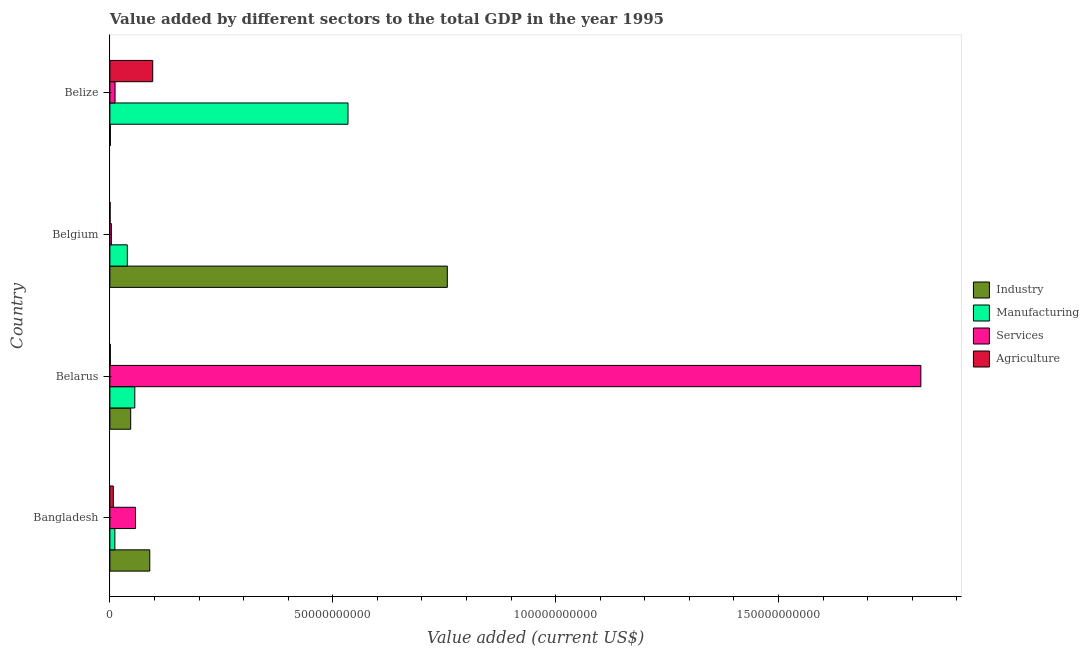Are the number of bars per tick equal to the number of legend labels?
Offer a terse response. Yes. Are the number of bars on each tick of the Y-axis equal?
Provide a short and direct response. Yes. How many bars are there on the 4th tick from the bottom?
Ensure brevity in your answer.  4. What is the label of the 3rd group of bars from the top?
Your response must be concise. Belarus. What is the value added by manufacturing sector in Belarus?
Provide a short and direct response. 5.59e+09. Across all countries, what is the maximum value added by industrial sector?
Offer a very short reply. 7.57e+1. Across all countries, what is the minimum value added by services sector?
Provide a short and direct response. 3.32e+08. In which country was the value added by services sector maximum?
Offer a terse response. Belarus. What is the total value added by agricultural sector in the graph?
Make the answer very short. 1.05e+1. What is the difference between the value added by industrial sector in Bangladesh and that in Belgium?
Your answer should be very brief. -6.68e+1. What is the difference between the value added by industrial sector in Belgium and the value added by manufacturing sector in Belize?
Your answer should be compact. 2.23e+1. What is the average value added by agricultural sector per country?
Keep it short and to the point. 2.63e+09. What is the difference between the value added by manufacturing sector and value added by services sector in Belgium?
Give a very brief answer. 3.58e+09. In how many countries, is the value added by services sector greater than 90000000000 US$?
Your response must be concise. 1. What is the ratio of the value added by services sector in Belarus to that in Belgium?
Give a very brief answer. 548.52. What is the difference between the highest and the second highest value added by agricultural sector?
Ensure brevity in your answer.  8.84e+09. What is the difference between the highest and the lowest value added by manufacturing sector?
Your answer should be very brief. 5.23e+1. In how many countries, is the value added by industrial sector greater than the average value added by industrial sector taken over all countries?
Your answer should be very brief. 1. Is the sum of the value added by services sector in Belarus and Belize greater than the maximum value added by manufacturing sector across all countries?
Provide a short and direct response. Yes. Is it the case that in every country, the sum of the value added by agricultural sector and value added by industrial sector is greater than the sum of value added by services sector and value added by manufacturing sector?
Give a very brief answer. No. What does the 3rd bar from the top in Belize represents?
Your answer should be very brief. Manufacturing. What does the 1st bar from the bottom in Belize represents?
Your answer should be compact. Industry. Is it the case that in every country, the sum of the value added by industrial sector and value added by manufacturing sector is greater than the value added by services sector?
Keep it short and to the point. No. How many countries are there in the graph?
Keep it short and to the point. 4. What is the difference between two consecutive major ticks on the X-axis?
Your answer should be very brief. 5.00e+1. Are the values on the major ticks of X-axis written in scientific E-notation?
Your answer should be compact. No. Where does the legend appear in the graph?
Your answer should be compact. Center right. What is the title of the graph?
Your answer should be compact. Value added by different sectors to the total GDP in the year 1995. Does "Debt policy" appear as one of the legend labels in the graph?
Offer a terse response. No. What is the label or title of the X-axis?
Your response must be concise. Value added (current US$). What is the Value added (current US$) of Industry in Bangladesh?
Provide a short and direct response. 8.95e+09. What is the Value added (current US$) in Manufacturing in Bangladesh?
Provide a short and direct response. 1.11e+09. What is the Value added (current US$) in Services in Bangladesh?
Your response must be concise. 5.75e+09. What is the Value added (current US$) in Agriculture in Bangladesh?
Provide a succinct answer. 7.68e+08. What is the Value added (current US$) of Industry in Belarus?
Your answer should be compact. 4.66e+09. What is the Value added (current US$) of Manufacturing in Belarus?
Your answer should be very brief. 5.59e+09. What is the Value added (current US$) of Services in Belarus?
Give a very brief answer. 1.82e+11. What is the Value added (current US$) of Agriculture in Belarus?
Ensure brevity in your answer.  9.72e+07. What is the Value added (current US$) in Industry in Belgium?
Your answer should be compact. 7.57e+1. What is the Value added (current US$) in Manufacturing in Belgium?
Provide a succinct answer. 3.91e+09. What is the Value added (current US$) of Services in Belgium?
Ensure brevity in your answer.  3.32e+08. What is the Value added (current US$) of Agriculture in Belgium?
Provide a succinct answer. 5.05e+07. What is the Value added (current US$) of Industry in Belize?
Offer a very short reply. 1.08e+08. What is the Value added (current US$) of Manufacturing in Belize?
Offer a terse response. 5.34e+1. What is the Value added (current US$) of Services in Belize?
Keep it short and to the point. 1.16e+09. What is the Value added (current US$) in Agriculture in Belize?
Offer a very short reply. 9.61e+09. Across all countries, what is the maximum Value added (current US$) of Industry?
Offer a terse response. 7.57e+1. Across all countries, what is the maximum Value added (current US$) in Manufacturing?
Your answer should be very brief. 5.34e+1. Across all countries, what is the maximum Value added (current US$) in Services?
Provide a short and direct response. 1.82e+11. Across all countries, what is the maximum Value added (current US$) in Agriculture?
Provide a succinct answer. 9.61e+09. Across all countries, what is the minimum Value added (current US$) in Industry?
Ensure brevity in your answer.  1.08e+08. Across all countries, what is the minimum Value added (current US$) in Manufacturing?
Give a very brief answer. 1.11e+09. Across all countries, what is the minimum Value added (current US$) of Services?
Give a very brief answer. 3.32e+08. Across all countries, what is the minimum Value added (current US$) of Agriculture?
Keep it short and to the point. 5.05e+07. What is the total Value added (current US$) in Industry in the graph?
Your answer should be very brief. 8.94e+1. What is the total Value added (current US$) in Manufacturing in the graph?
Offer a very short reply. 6.40e+1. What is the total Value added (current US$) of Services in the graph?
Your answer should be compact. 1.89e+11. What is the total Value added (current US$) of Agriculture in the graph?
Offer a very short reply. 1.05e+1. What is the difference between the Value added (current US$) of Industry in Bangladesh and that in Belarus?
Provide a short and direct response. 4.28e+09. What is the difference between the Value added (current US$) of Manufacturing in Bangladesh and that in Belarus?
Ensure brevity in your answer.  -4.47e+09. What is the difference between the Value added (current US$) of Services in Bangladesh and that in Belarus?
Your answer should be very brief. -1.76e+11. What is the difference between the Value added (current US$) of Agriculture in Bangladesh and that in Belarus?
Make the answer very short. 6.71e+08. What is the difference between the Value added (current US$) of Industry in Bangladesh and that in Belgium?
Your response must be concise. -6.68e+1. What is the difference between the Value added (current US$) in Manufacturing in Bangladesh and that in Belgium?
Give a very brief answer. -2.79e+09. What is the difference between the Value added (current US$) of Services in Bangladesh and that in Belgium?
Your response must be concise. 5.42e+09. What is the difference between the Value added (current US$) in Agriculture in Bangladesh and that in Belgium?
Your answer should be very brief. 7.18e+08. What is the difference between the Value added (current US$) in Industry in Bangladesh and that in Belize?
Your answer should be compact. 8.84e+09. What is the difference between the Value added (current US$) in Manufacturing in Bangladesh and that in Belize?
Keep it short and to the point. -5.23e+1. What is the difference between the Value added (current US$) in Services in Bangladesh and that in Belize?
Offer a terse response. 4.59e+09. What is the difference between the Value added (current US$) in Agriculture in Bangladesh and that in Belize?
Keep it short and to the point. -8.84e+09. What is the difference between the Value added (current US$) of Industry in Belarus and that in Belgium?
Make the answer very short. -7.10e+1. What is the difference between the Value added (current US$) in Manufacturing in Belarus and that in Belgium?
Give a very brief answer. 1.68e+09. What is the difference between the Value added (current US$) of Services in Belarus and that in Belgium?
Your answer should be very brief. 1.82e+11. What is the difference between the Value added (current US$) in Agriculture in Belarus and that in Belgium?
Give a very brief answer. 4.67e+07. What is the difference between the Value added (current US$) in Industry in Belarus and that in Belize?
Your response must be concise. 4.56e+09. What is the difference between the Value added (current US$) in Manufacturing in Belarus and that in Belize?
Ensure brevity in your answer.  -4.78e+1. What is the difference between the Value added (current US$) of Services in Belarus and that in Belize?
Keep it short and to the point. 1.81e+11. What is the difference between the Value added (current US$) of Agriculture in Belarus and that in Belize?
Make the answer very short. -9.51e+09. What is the difference between the Value added (current US$) of Industry in Belgium and that in Belize?
Keep it short and to the point. 7.56e+1. What is the difference between the Value added (current US$) of Manufacturing in Belgium and that in Belize?
Make the answer very short. -4.95e+1. What is the difference between the Value added (current US$) in Services in Belgium and that in Belize?
Ensure brevity in your answer.  -8.29e+08. What is the difference between the Value added (current US$) of Agriculture in Belgium and that in Belize?
Provide a succinct answer. -9.56e+09. What is the difference between the Value added (current US$) of Industry in Bangladesh and the Value added (current US$) of Manufacturing in Belarus?
Offer a terse response. 3.36e+09. What is the difference between the Value added (current US$) of Industry in Bangladesh and the Value added (current US$) of Services in Belarus?
Give a very brief answer. -1.73e+11. What is the difference between the Value added (current US$) in Industry in Bangladesh and the Value added (current US$) in Agriculture in Belarus?
Your response must be concise. 8.85e+09. What is the difference between the Value added (current US$) in Manufacturing in Bangladesh and the Value added (current US$) in Services in Belarus?
Your response must be concise. -1.81e+11. What is the difference between the Value added (current US$) in Manufacturing in Bangladesh and the Value added (current US$) in Agriculture in Belarus?
Make the answer very short. 1.02e+09. What is the difference between the Value added (current US$) in Services in Bangladesh and the Value added (current US$) in Agriculture in Belarus?
Ensure brevity in your answer.  5.65e+09. What is the difference between the Value added (current US$) in Industry in Bangladesh and the Value added (current US$) in Manufacturing in Belgium?
Make the answer very short. 5.04e+09. What is the difference between the Value added (current US$) of Industry in Bangladesh and the Value added (current US$) of Services in Belgium?
Provide a succinct answer. 8.61e+09. What is the difference between the Value added (current US$) in Industry in Bangladesh and the Value added (current US$) in Agriculture in Belgium?
Provide a succinct answer. 8.90e+09. What is the difference between the Value added (current US$) of Manufacturing in Bangladesh and the Value added (current US$) of Services in Belgium?
Your response must be concise. 7.83e+08. What is the difference between the Value added (current US$) in Manufacturing in Bangladesh and the Value added (current US$) in Agriculture in Belgium?
Offer a very short reply. 1.06e+09. What is the difference between the Value added (current US$) of Services in Bangladesh and the Value added (current US$) of Agriculture in Belgium?
Keep it short and to the point. 5.70e+09. What is the difference between the Value added (current US$) in Industry in Bangladesh and the Value added (current US$) in Manufacturing in Belize?
Make the answer very short. -4.45e+1. What is the difference between the Value added (current US$) of Industry in Bangladesh and the Value added (current US$) of Services in Belize?
Offer a very short reply. 7.79e+09. What is the difference between the Value added (current US$) of Industry in Bangladesh and the Value added (current US$) of Agriculture in Belize?
Give a very brief answer. -6.65e+08. What is the difference between the Value added (current US$) in Manufacturing in Bangladesh and the Value added (current US$) in Services in Belize?
Your answer should be very brief. -4.66e+07. What is the difference between the Value added (current US$) of Manufacturing in Bangladesh and the Value added (current US$) of Agriculture in Belize?
Your response must be concise. -8.50e+09. What is the difference between the Value added (current US$) in Services in Bangladesh and the Value added (current US$) in Agriculture in Belize?
Provide a short and direct response. -3.86e+09. What is the difference between the Value added (current US$) of Industry in Belarus and the Value added (current US$) of Manufacturing in Belgium?
Offer a terse response. 7.55e+08. What is the difference between the Value added (current US$) in Industry in Belarus and the Value added (current US$) in Services in Belgium?
Ensure brevity in your answer.  4.33e+09. What is the difference between the Value added (current US$) in Industry in Belarus and the Value added (current US$) in Agriculture in Belgium?
Keep it short and to the point. 4.61e+09. What is the difference between the Value added (current US$) in Manufacturing in Belarus and the Value added (current US$) in Services in Belgium?
Ensure brevity in your answer.  5.25e+09. What is the difference between the Value added (current US$) of Manufacturing in Belarus and the Value added (current US$) of Agriculture in Belgium?
Offer a terse response. 5.54e+09. What is the difference between the Value added (current US$) of Services in Belarus and the Value added (current US$) of Agriculture in Belgium?
Ensure brevity in your answer.  1.82e+11. What is the difference between the Value added (current US$) of Industry in Belarus and the Value added (current US$) of Manufacturing in Belize?
Give a very brief answer. -4.88e+1. What is the difference between the Value added (current US$) in Industry in Belarus and the Value added (current US$) in Services in Belize?
Your answer should be compact. 3.50e+09. What is the difference between the Value added (current US$) of Industry in Belarus and the Value added (current US$) of Agriculture in Belize?
Ensure brevity in your answer.  -4.95e+09. What is the difference between the Value added (current US$) of Manufacturing in Belarus and the Value added (current US$) of Services in Belize?
Your answer should be compact. 4.42e+09. What is the difference between the Value added (current US$) in Manufacturing in Belarus and the Value added (current US$) in Agriculture in Belize?
Make the answer very short. -4.03e+09. What is the difference between the Value added (current US$) of Services in Belarus and the Value added (current US$) of Agriculture in Belize?
Your answer should be very brief. 1.72e+11. What is the difference between the Value added (current US$) of Industry in Belgium and the Value added (current US$) of Manufacturing in Belize?
Ensure brevity in your answer.  2.23e+1. What is the difference between the Value added (current US$) of Industry in Belgium and the Value added (current US$) of Services in Belize?
Keep it short and to the point. 7.45e+1. What is the difference between the Value added (current US$) of Industry in Belgium and the Value added (current US$) of Agriculture in Belize?
Your answer should be compact. 6.61e+1. What is the difference between the Value added (current US$) of Manufacturing in Belgium and the Value added (current US$) of Services in Belize?
Offer a very short reply. 2.75e+09. What is the difference between the Value added (current US$) of Manufacturing in Belgium and the Value added (current US$) of Agriculture in Belize?
Ensure brevity in your answer.  -5.70e+09. What is the difference between the Value added (current US$) in Services in Belgium and the Value added (current US$) in Agriculture in Belize?
Provide a short and direct response. -9.28e+09. What is the average Value added (current US$) of Industry per country?
Your response must be concise. 2.24e+1. What is the average Value added (current US$) of Manufacturing per country?
Make the answer very short. 1.60e+1. What is the average Value added (current US$) in Services per country?
Your response must be concise. 4.73e+1. What is the average Value added (current US$) of Agriculture per country?
Your response must be concise. 2.63e+09. What is the difference between the Value added (current US$) of Industry and Value added (current US$) of Manufacturing in Bangladesh?
Provide a succinct answer. 7.83e+09. What is the difference between the Value added (current US$) in Industry and Value added (current US$) in Services in Bangladesh?
Ensure brevity in your answer.  3.20e+09. What is the difference between the Value added (current US$) of Industry and Value added (current US$) of Agriculture in Bangladesh?
Offer a terse response. 8.18e+09. What is the difference between the Value added (current US$) in Manufacturing and Value added (current US$) in Services in Bangladesh?
Provide a succinct answer. -4.64e+09. What is the difference between the Value added (current US$) of Manufacturing and Value added (current US$) of Agriculture in Bangladesh?
Offer a terse response. 3.46e+08. What is the difference between the Value added (current US$) in Services and Value added (current US$) in Agriculture in Bangladesh?
Give a very brief answer. 4.98e+09. What is the difference between the Value added (current US$) in Industry and Value added (current US$) in Manufacturing in Belarus?
Offer a terse response. -9.22e+08. What is the difference between the Value added (current US$) of Industry and Value added (current US$) of Services in Belarus?
Make the answer very short. -1.77e+11. What is the difference between the Value added (current US$) in Industry and Value added (current US$) in Agriculture in Belarus?
Your answer should be compact. 4.57e+09. What is the difference between the Value added (current US$) in Manufacturing and Value added (current US$) in Services in Belarus?
Provide a short and direct response. -1.76e+11. What is the difference between the Value added (current US$) of Manufacturing and Value added (current US$) of Agriculture in Belarus?
Offer a terse response. 5.49e+09. What is the difference between the Value added (current US$) in Services and Value added (current US$) in Agriculture in Belarus?
Offer a terse response. 1.82e+11. What is the difference between the Value added (current US$) of Industry and Value added (current US$) of Manufacturing in Belgium?
Provide a succinct answer. 7.18e+1. What is the difference between the Value added (current US$) in Industry and Value added (current US$) in Services in Belgium?
Provide a succinct answer. 7.54e+1. What is the difference between the Value added (current US$) in Industry and Value added (current US$) in Agriculture in Belgium?
Your response must be concise. 7.57e+1. What is the difference between the Value added (current US$) in Manufacturing and Value added (current US$) in Services in Belgium?
Offer a very short reply. 3.58e+09. What is the difference between the Value added (current US$) in Manufacturing and Value added (current US$) in Agriculture in Belgium?
Your answer should be compact. 3.86e+09. What is the difference between the Value added (current US$) of Services and Value added (current US$) of Agriculture in Belgium?
Your response must be concise. 2.81e+08. What is the difference between the Value added (current US$) in Industry and Value added (current US$) in Manufacturing in Belize?
Provide a succinct answer. -5.33e+1. What is the difference between the Value added (current US$) in Industry and Value added (current US$) in Services in Belize?
Keep it short and to the point. -1.05e+09. What is the difference between the Value added (current US$) in Industry and Value added (current US$) in Agriculture in Belize?
Keep it short and to the point. -9.50e+09. What is the difference between the Value added (current US$) of Manufacturing and Value added (current US$) of Services in Belize?
Offer a terse response. 5.23e+1. What is the difference between the Value added (current US$) in Manufacturing and Value added (current US$) in Agriculture in Belize?
Offer a terse response. 4.38e+1. What is the difference between the Value added (current US$) in Services and Value added (current US$) in Agriculture in Belize?
Keep it short and to the point. -8.45e+09. What is the ratio of the Value added (current US$) of Industry in Bangladesh to that in Belarus?
Your response must be concise. 1.92. What is the ratio of the Value added (current US$) of Manufacturing in Bangladesh to that in Belarus?
Provide a succinct answer. 0.2. What is the ratio of the Value added (current US$) of Services in Bangladesh to that in Belarus?
Keep it short and to the point. 0.03. What is the ratio of the Value added (current US$) of Agriculture in Bangladesh to that in Belarus?
Keep it short and to the point. 7.91. What is the ratio of the Value added (current US$) of Industry in Bangladesh to that in Belgium?
Make the answer very short. 0.12. What is the ratio of the Value added (current US$) in Manufacturing in Bangladesh to that in Belgium?
Ensure brevity in your answer.  0.29. What is the ratio of the Value added (current US$) in Services in Bangladesh to that in Belgium?
Give a very brief answer. 17.34. What is the ratio of the Value added (current US$) of Agriculture in Bangladesh to that in Belgium?
Keep it short and to the point. 15.22. What is the ratio of the Value added (current US$) of Industry in Bangladesh to that in Belize?
Make the answer very short. 82.71. What is the ratio of the Value added (current US$) of Manufacturing in Bangladesh to that in Belize?
Make the answer very short. 0.02. What is the ratio of the Value added (current US$) in Services in Bangladesh to that in Belize?
Offer a terse response. 4.95. What is the ratio of the Value added (current US$) of Agriculture in Bangladesh to that in Belize?
Your answer should be compact. 0.08. What is the ratio of the Value added (current US$) of Industry in Belarus to that in Belgium?
Give a very brief answer. 0.06. What is the ratio of the Value added (current US$) in Manufacturing in Belarus to that in Belgium?
Ensure brevity in your answer.  1.43. What is the ratio of the Value added (current US$) of Services in Belarus to that in Belgium?
Your response must be concise. 548.52. What is the ratio of the Value added (current US$) in Agriculture in Belarus to that in Belgium?
Give a very brief answer. 1.93. What is the ratio of the Value added (current US$) in Industry in Belarus to that in Belize?
Offer a very short reply. 43.12. What is the ratio of the Value added (current US$) in Manufacturing in Belarus to that in Belize?
Provide a short and direct response. 0.1. What is the ratio of the Value added (current US$) in Services in Belarus to that in Belize?
Offer a very short reply. 156.69. What is the ratio of the Value added (current US$) in Agriculture in Belarus to that in Belize?
Keep it short and to the point. 0.01. What is the ratio of the Value added (current US$) of Industry in Belgium to that in Belize?
Provide a succinct answer. 699.82. What is the ratio of the Value added (current US$) in Manufacturing in Belgium to that in Belize?
Ensure brevity in your answer.  0.07. What is the ratio of the Value added (current US$) in Services in Belgium to that in Belize?
Provide a short and direct response. 0.29. What is the ratio of the Value added (current US$) in Agriculture in Belgium to that in Belize?
Your answer should be very brief. 0.01. What is the difference between the highest and the second highest Value added (current US$) of Industry?
Your answer should be very brief. 6.68e+1. What is the difference between the highest and the second highest Value added (current US$) of Manufacturing?
Provide a short and direct response. 4.78e+1. What is the difference between the highest and the second highest Value added (current US$) of Services?
Provide a succinct answer. 1.76e+11. What is the difference between the highest and the second highest Value added (current US$) in Agriculture?
Provide a short and direct response. 8.84e+09. What is the difference between the highest and the lowest Value added (current US$) in Industry?
Your answer should be compact. 7.56e+1. What is the difference between the highest and the lowest Value added (current US$) in Manufacturing?
Your answer should be compact. 5.23e+1. What is the difference between the highest and the lowest Value added (current US$) in Services?
Your response must be concise. 1.82e+11. What is the difference between the highest and the lowest Value added (current US$) in Agriculture?
Provide a succinct answer. 9.56e+09. 